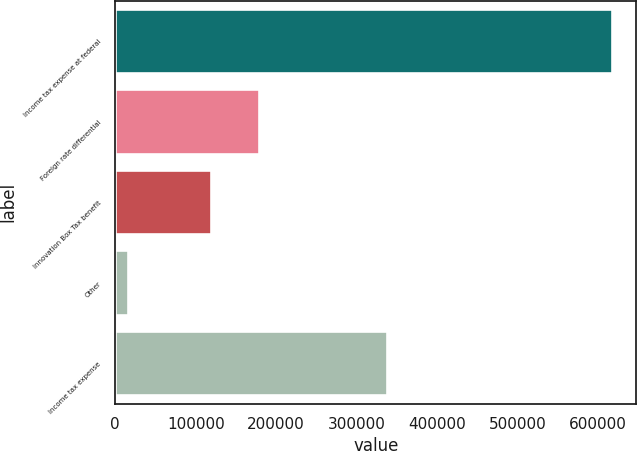Convert chart. <chart><loc_0><loc_0><loc_500><loc_500><bar_chart><fcel>Income tax expense at federal<fcel>Foreign rate differential<fcel>Innovation Box Tax benefit<fcel>Other<fcel>Income tax expense<nl><fcel>616654<fcel>178979<fcel>118916<fcel>16026<fcel>337832<nl></chart> 